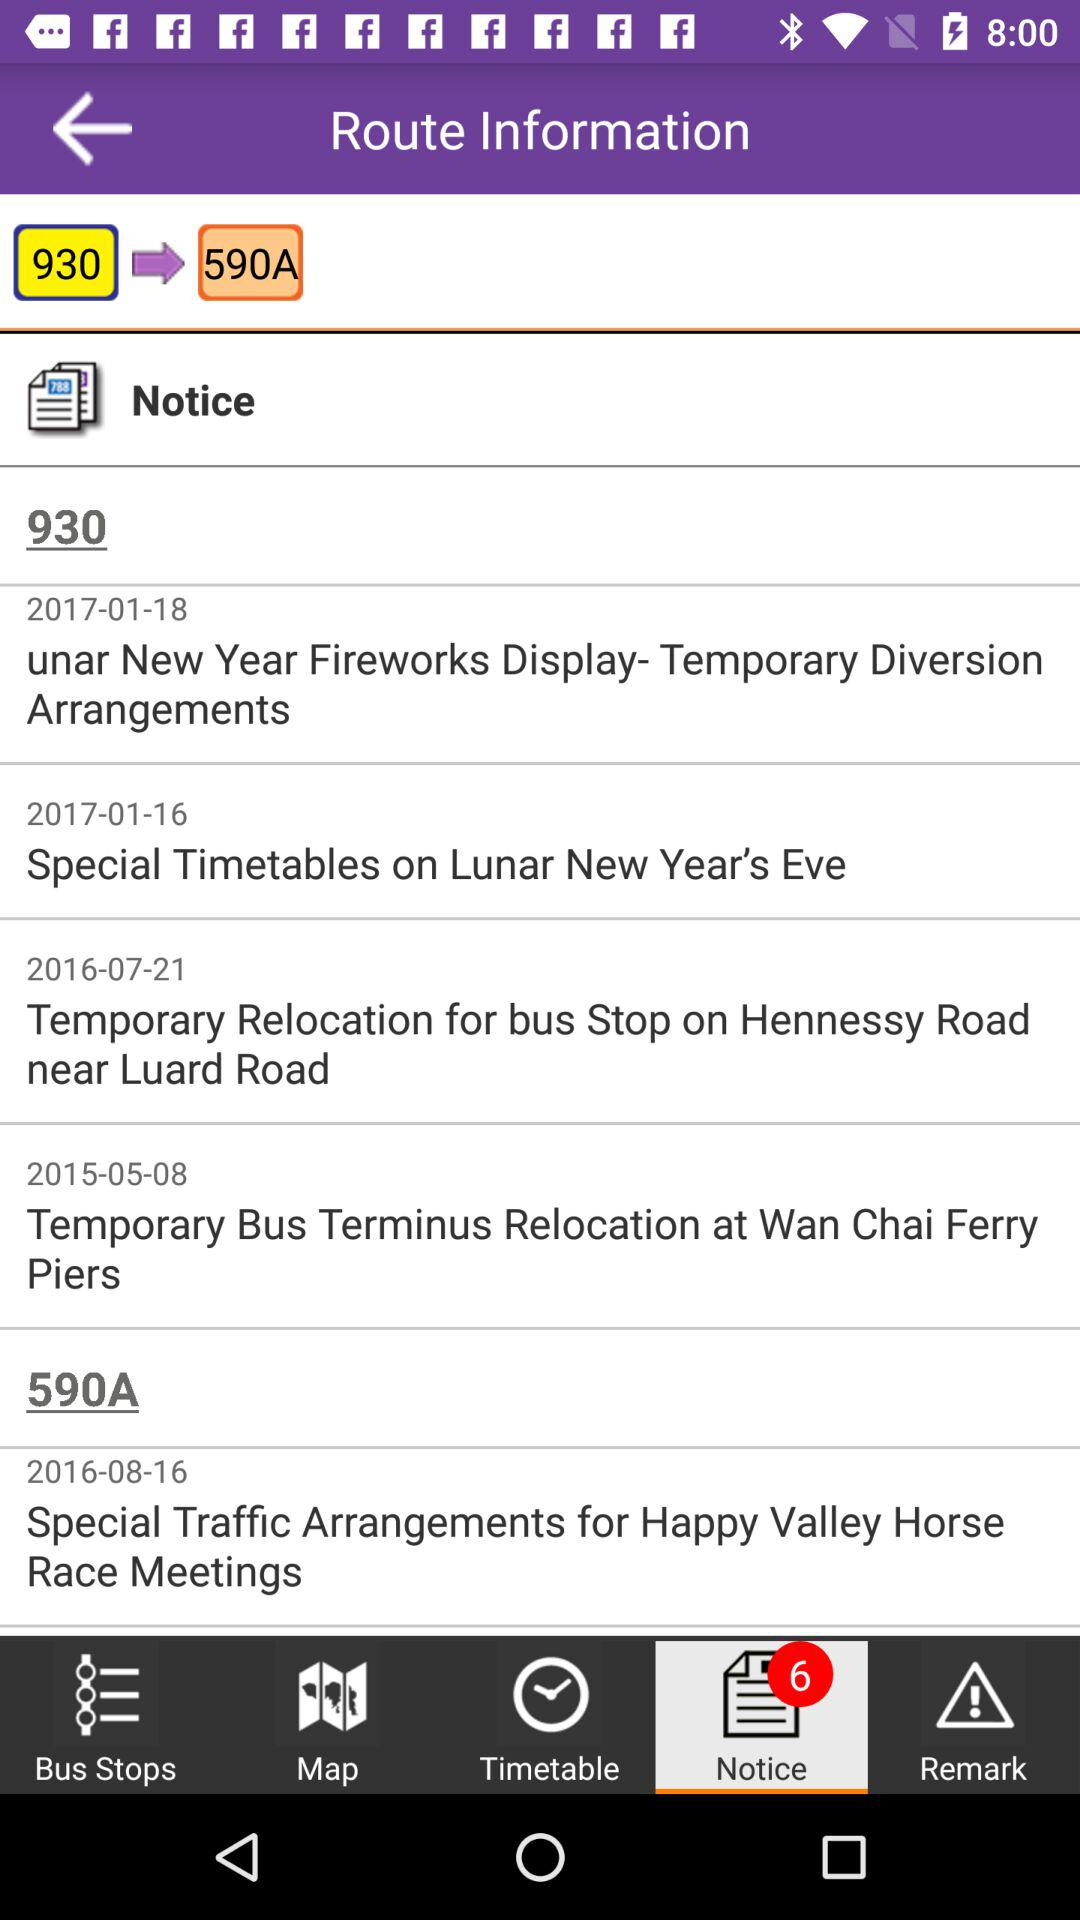How many notifications are there in "Map"?
When the provided information is insufficient, respond with <no answer>. <no answer> 